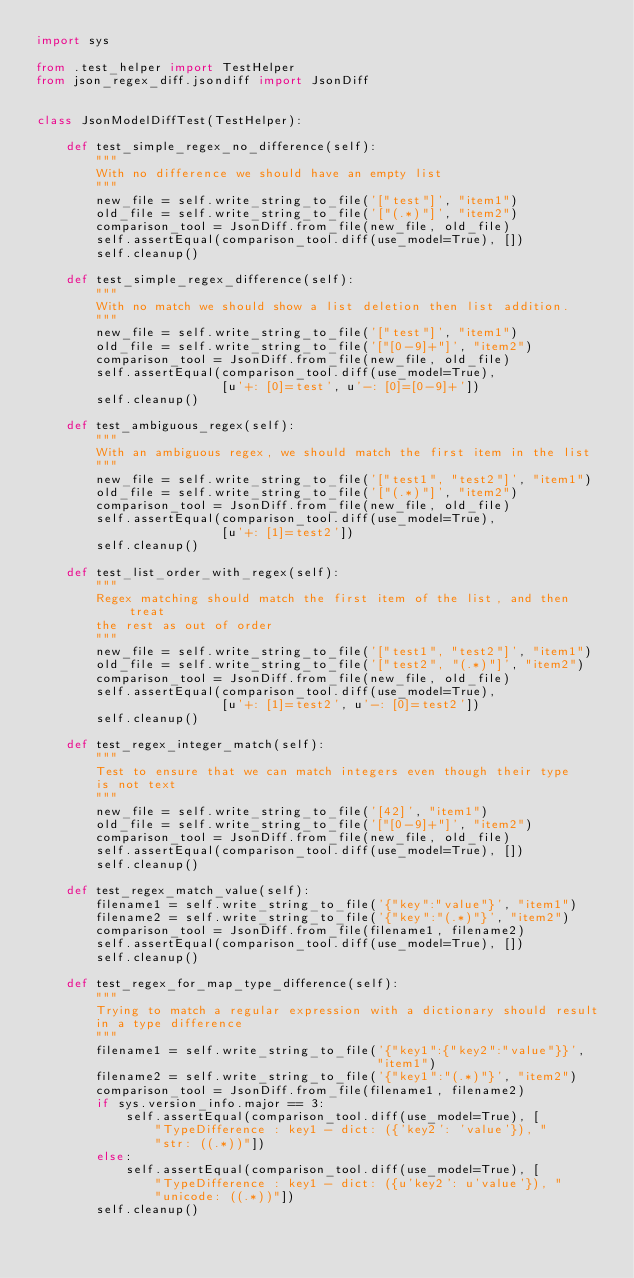<code> <loc_0><loc_0><loc_500><loc_500><_Python_>import sys

from .test_helper import TestHelper
from json_regex_diff.jsondiff import JsonDiff


class JsonModelDiffTest(TestHelper):

    def test_simple_regex_no_difference(self):
        """
        With no difference we should have an empty list
        """
        new_file = self.write_string_to_file('["test"]', "item1")
        old_file = self.write_string_to_file('["(.*)"]', "item2")
        comparison_tool = JsonDiff.from_file(new_file, old_file)
        self.assertEqual(comparison_tool.diff(use_model=True), [])
        self.cleanup()

    def test_simple_regex_difference(self):
        """
        With no match we should show a list deletion then list addition.
        """
        new_file = self.write_string_to_file('["test"]', "item1")
        old_file = self.write_string_to_file('["[0-9]+"]', "item2")
        comparison_tool = JsonDiff.from_file(new_file, old_file)
        self.assertEqual(comparison_tool.diff(use_model=True),
                         [u'+: [0]=test', u'-: [0]=[0-9]+'])
        self.cleanup()

    def test_ambiguous_regex(self):
        """
        With an ambiguous regex, we should match the first item in the list
        """
        new_file = self.write_string_to_file('["test1", "test2"]', "item1")
        old_file = self.write_string_to_file('["(.*)"]', "item2")
        comparison_tool = JsonDiff.from_file(new_file, old_file)
        self.assertEqual(comparison_tool.diff(use_model=True),
                         [u'+: [1]=test2'])
        self.cleanup()

    def test_list_order_with_regex(self):
        """
        Regex matching should match the first item of the list, and then treat
        the rest as out of order
        """
        new_file = self.write_string_to_file('["test1", "test2"]', "item1")
        old_file = self.write_string_to_file('["test2", "(.*)"]', "item2")
        comparison_tool = JsonDiff.from_file(new_file, old_file)
        self.assertEqual(comparison_tool.diff(use_model=True),
                         [u'+: [1]=test2', u'-: [0]=test2'])
        self.cleanup()

    def test_regex_integer_match(self):
        """
        Test to ensure that we can match integers even though their type
        is not text
        """
        new_file = self.write_string_to_file('[42]', "item1")
        old_file = self.write_string_to_file('["[0-9]+"]', "item2")
        comparison_tool = JsonDiff.from_file(new_file, old_file)
        self.assertEqual(comparison_tool.diff(use_model=True), [])
        self.cleanup()

    def test_regex_match_value(self):
        filename1 = self.write_string_to_file('{"key":"value"}', "item1")
        filename2 = self.write_string_to_file('{"key":"(.*)"}', "item2")
        comparison_tool = JsonDiff.from_file(filename1, filename2)
        self.assertEqual(comparison_tool.diff(use_model=True), [])
        self.cleanup()

    def test_regex_for_map_type_difference(self):
        """
        Trying to match a regular expression with a dictionary should result
        in a type difference
        """
        filename1 = self.write_string_to_file('{"key1":{"key2":"value"}}',
                                              "item1")
        filename2 = self.write_string_to_file('{"key1":"(.*)"}', "item2")
        comparison_tool = JsonDiff.from_file(filename1, filename2)
        if sys.version_info.major == 3:
            self.assertEqual(comparison_tool.diff(use_model=True), [
                "TypeDifference : key1 - dict: ({'key2': 'value'}), "
                "str: ((.*))"])
        else:
            self.assertEqual(comparison_tool.diff(use_model=True), [
                "TypeDifference : key1 - dict: ({u'key2': u'value'}), "
                "unicode: ((.*))"])
        self.cleanup()
</code> 